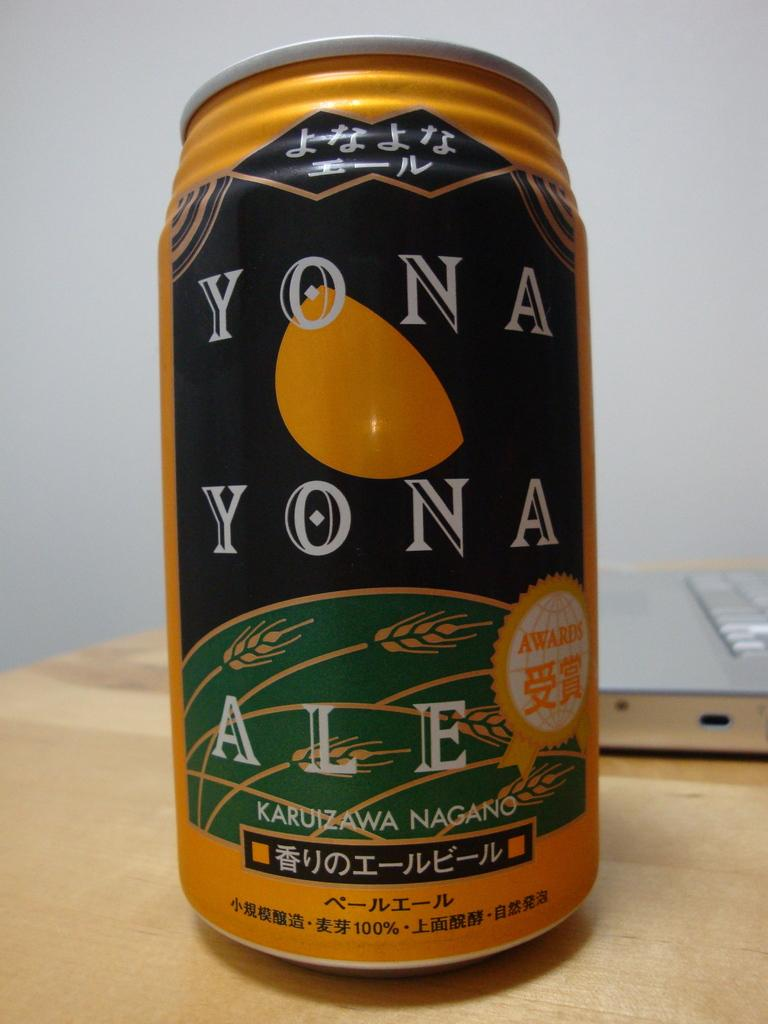Provide a one-sentence caption for the provided image. A can of Yona Yona Ale from Nagano sits on a desk. 